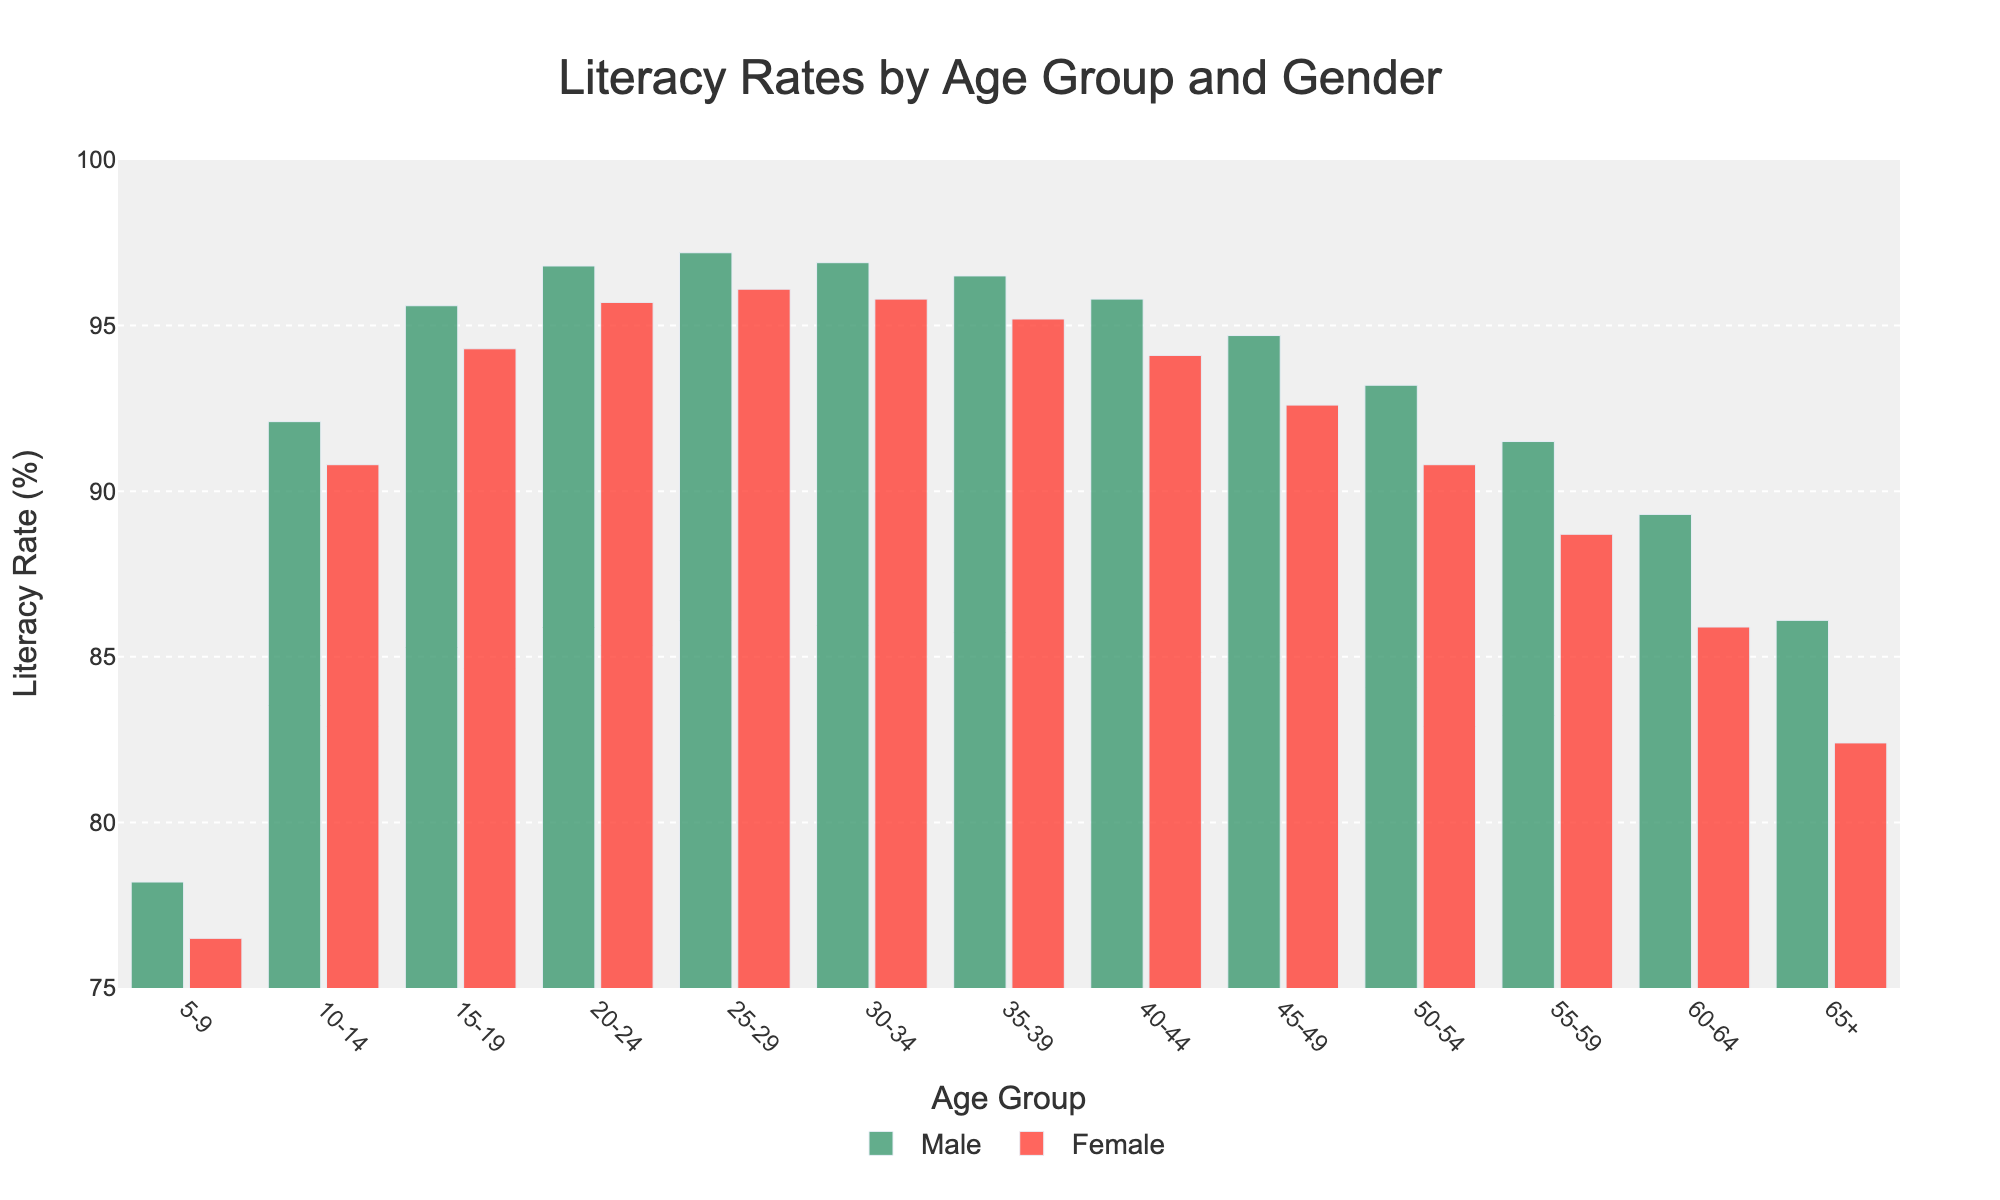What is the literacy rate for females aged 25-29? Look at the bar corresponding to the age group 25-29 and note the height of the female's bar. It shows 96.1%.
Answer: 96.1% Which age group has the lowest literacy rate for males? Look at the height of all green bars (male). The shortest bar corresponds to the 65+ age group, showing 86.1%.
Answer: 65+ Is the literacy rate difference between males and females greater in the 60-64 age group or the 5-9 age group? Calculate the difference for both age groups. For 60-64: 89.3 - 85.9 = 3.4. For 5-9: 78.2 - 76.5 = 1.7. Comparing these, the 60-64 age group has a greater difference.
Answer: 60-64 What is the overall trend in literacy rates for both genders as age increases? Observe the pattern of the bars from left to right. Both male and female literacy rates tend to decrease as age increases.
Answer: Decreasing In which age group is the female literacy rate closest to 90%? Examine the height of the red bars (female) and find the one closest to 90%. For the 50-54 age group, the rate is 90.8%, which is closest to 90%.
Answer: 50-54 How much higher is the male literacy rate than the female literacy rate in the 15-19 age group? Subtract the female literacy rate from the male literacy rate for the 15-19 age group: 95.6 - 94.3 = 1.3.
Answer: 1.3 Which gender shows a more significant decline in literacy rates from the age group 20-24 to 65+? Compare changes in literacy rates for both genders. For males: 96.8 (20-24) to 86.1 (65+) implies a drop of 10.7. For females: 95.7 (20-24) to 82.4 (65+) implies a drop of 13.3. Thus, females experience a more significant decline.
Answer: Females What is the average literacy rate for males across all age groups? Sum the male literacy rates and divide by the number of age groups: (78.2+92.1+95.6+96.8+97.2+96.9+96.5+95.8+94.7+93.2+91.5+89.3+86.1)/13 ≈ 92.41.
Answer: 92.41 Which age group has the smallest difference in literacy rates between males and females? Calculate the differences for each age group and identify the smallest. The smallest difference occurs in the 30-34 age group: 96.9 - 95.8 = 1.1.
Answer: 30-34 How much does the literacy rate for females decrease from the 45-49 age group to the 65+ age group? Subtract the literacy rate for females in the 65+ group from the 45-49 group: 92.6 - 82.4 = 10.2.
Answer: 10.2 